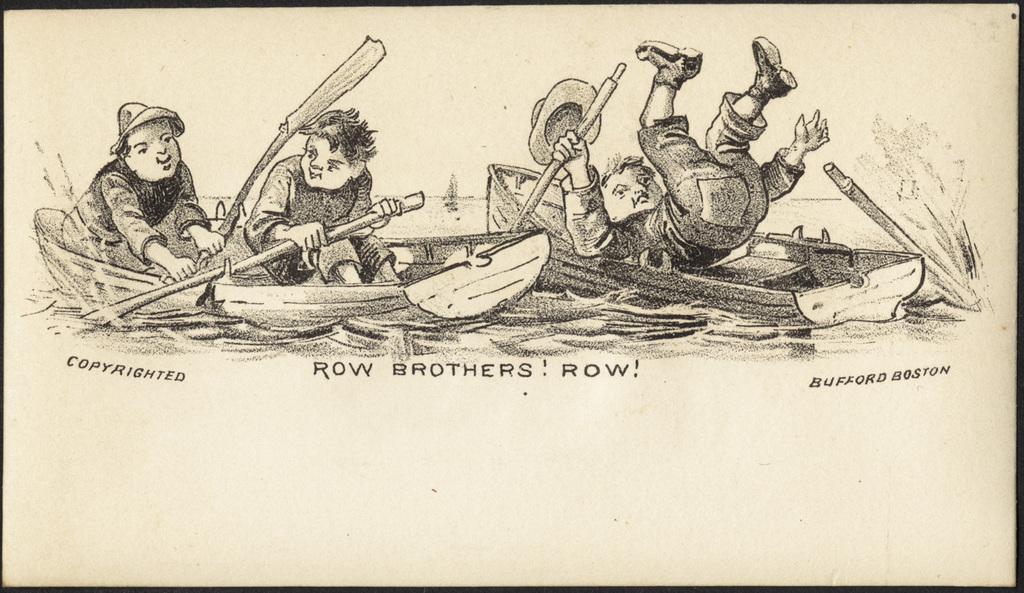Please provide a concise description of this image. In this image I can see a drawing of three kids in boats. Two of them are paddling in the same boat. I can see another kid in another boat and falling down. I can see some text below the drawing.  